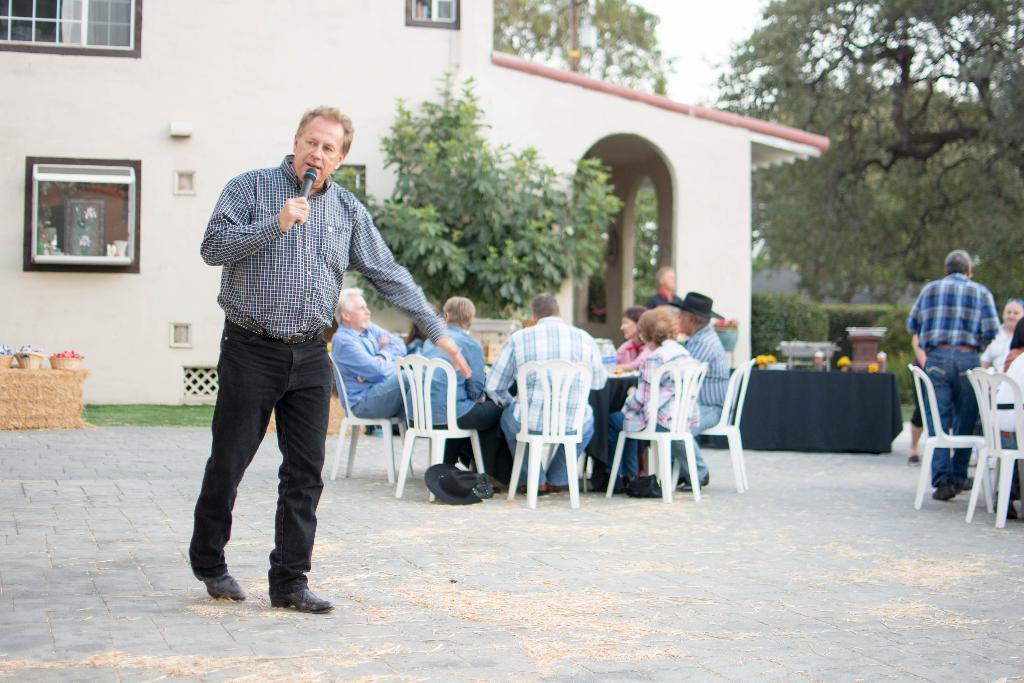Could you give a brief overview of what you see in this image? In the picture we can see a man talking into microphone and standing and we can see some people are sitting on a chairs around the table and some set of people are sitting on the other chairs, in the background we can see plant, a house building, with windows and trees and sky. 